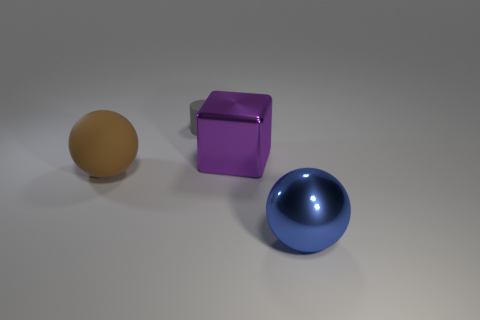Subtract all brown balls. How many balls are left? 1 Add 4 metal balls. How many objects exist? 8 Subtract all cylinders. How many objects are left? 3 Subtract all blue cylinders. How many brown spheres are left? 1 Subtract all small blue metallic things. Subtract all small gray things. How many objects are left? 3 Add 4 big blue objects. How many big blue objects are left? 5 Add 4 big purple metal things. How many big purple metal things exist? 5 Subtract 0 yellow cylinders. How many objects are left? 4 Subtract all green cylinders. Subtract all green spheres. How many cylinders are left? 1 